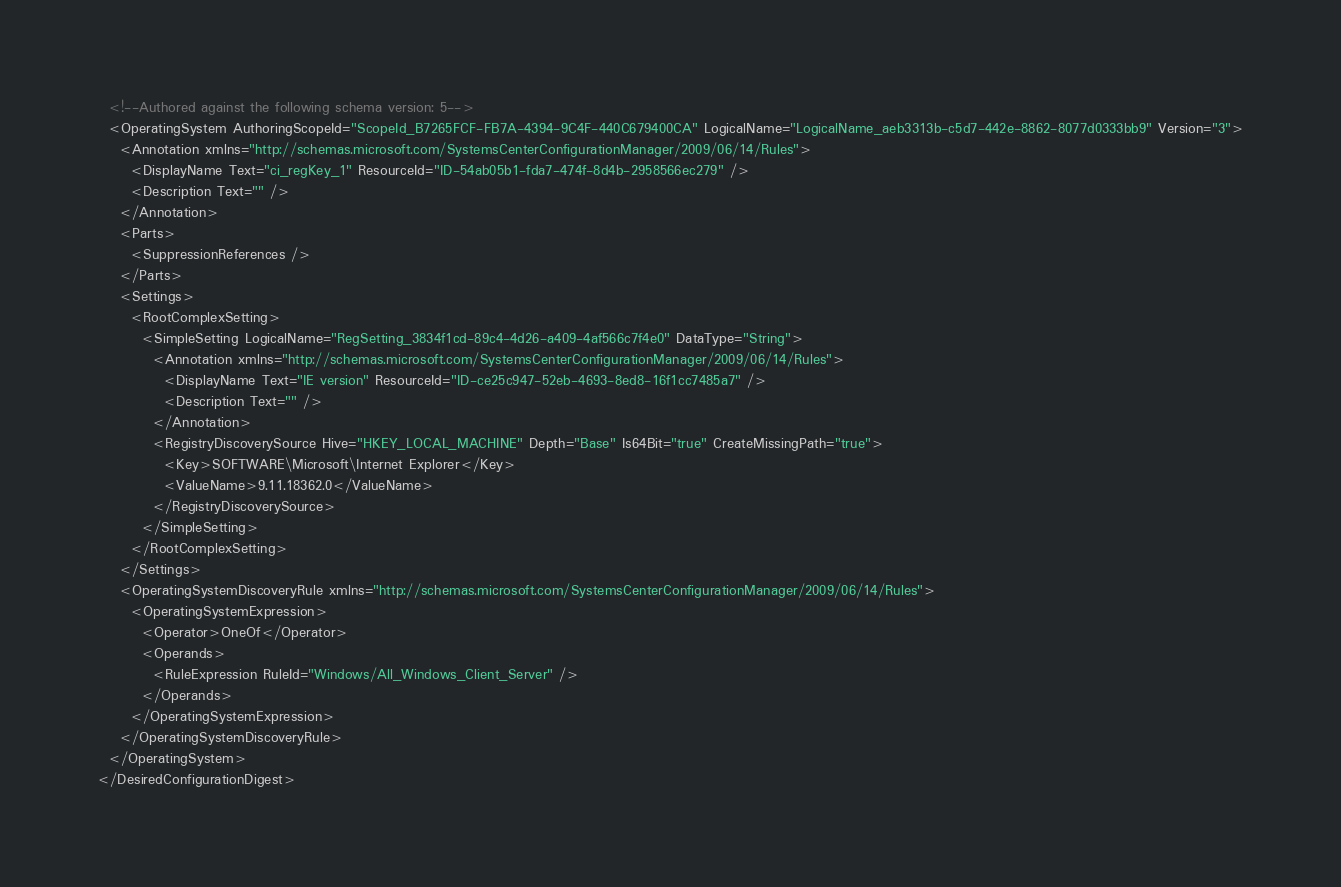<code> <loc_0><loc_0><loc_500><loc_500><_XML_>  <!--Authored against the following schema version: 5-->
  <OperatingSystem AuthoringScopeId="ScopeId_B7265FCF-FB7A-4394-9C4F-440C679400CA" LogicalName="LogicalName_aeb3313b-c5d7-442e-8862-8077d0333bb9" Version="3">
    <Annotation xmlns="http://schemas.microsoft.com/SystemsCenterConfigurationManager/2009/06/14/Rules">
      <DisplayName Text="ci_regKey_1" ResourceId="ID-54ab05b1-fda7-474f-8d4b-2958566ec279" />
      <Description Text="" />
    </Annotation>
    <Parts>
      <SuppressionReferences />
    </Parts>
    <Settings>
      <RootComplexSetting>
        <SimpleSetting LogicalName="RegSetting_3834f1cd-89c4-4d26-a409-4af566c7f4e0" DataType="String">
          <Annotation xmlns="http://schemas.microsoft.com/SystemsCenterConfigurationManager/2009/06/14/Rules">
            <DisplayName Text="IE version" ResourceId="ID-ce25c947-52eb-4693-8ed8-16f1cc7485a7" />
            <Description Text="" />
          </Annotation>
          <RegistryDiscoverySource Hive="HKEY_LOCAL_MACHINE" Depth="Base" Is64Bit="true" CreateMissingPath="true">
            <Key>SOFTWARE\Microsoft\Internet Explorer</Key>
            <ValueName>9.11.18362.0</ValueName>
          </RegistryDiscoverySource>
        </SimpleSetting>
      </RootComplexSetting>
    </Settings>
    <OperatingSystemDiscoveryRule xmlns="http://schemas.microsoft.com/SystemsCenterConfigurationManager/2009/06/14/Rules">
      <OperatingSystemExpression>
        <Operator>OneOf</Operator>
        <Operands>
          <RuleExpression RuleId="Windows/All_Windows_Client_Server" />
        </Operands>
      </OperatingSystemExpression>
    </OperatingSystemDiscoveryRule>
  </OperatingSystem>
</DesiredConfigurationDigest></code> 